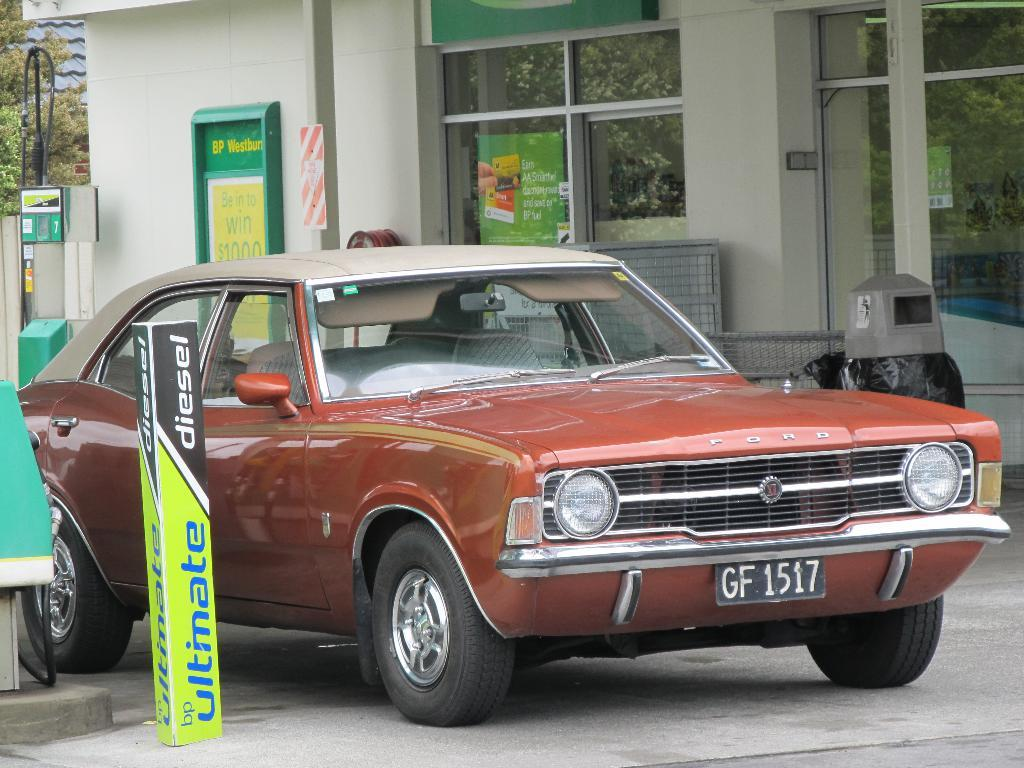What is parked on the road in the image? There is a car parked on the road in the image. What is located behind the car? There is a dustbin behind the car. What can be seen at the back side of the image? There is a building visible at the back side of the image. What type of vegetation is present at the left side of the image? Trees are present at the left side of the image. How does the family adjust the grain in the image? There is no family or grain present in the image. 